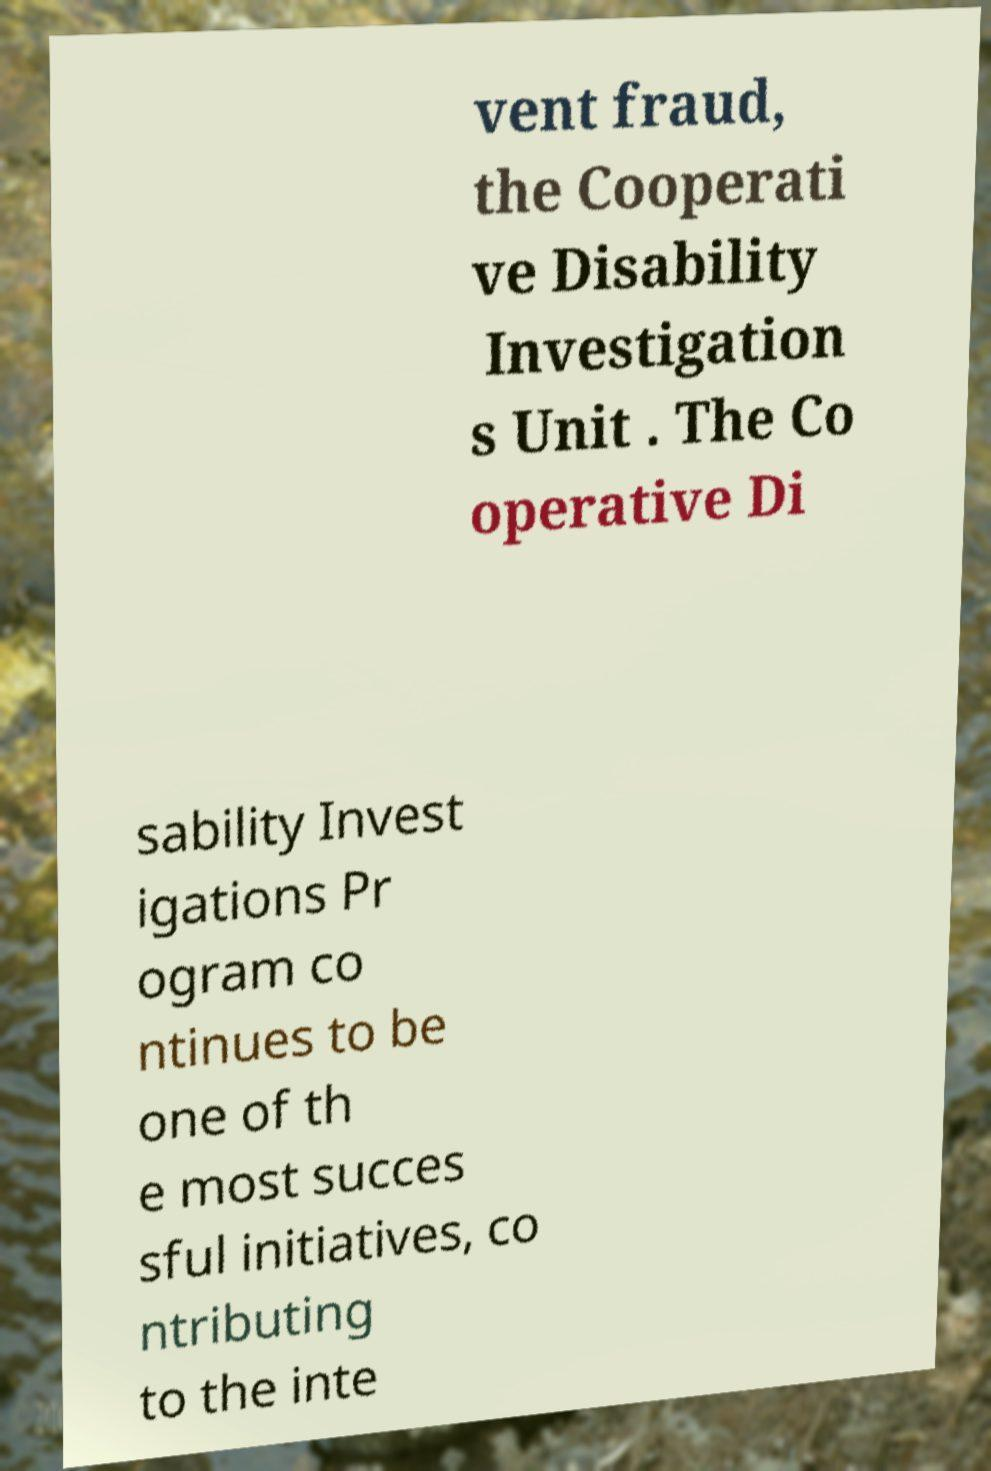Please read and relay the text visible in this image. What does it say? vent fraud, the Cooperati ve Disability Investigation s Unit . The Co operative Di sability Invest igations Pr ogram co ntinues to be one of th e most succes sful initiatives, co ntributing to the inte 